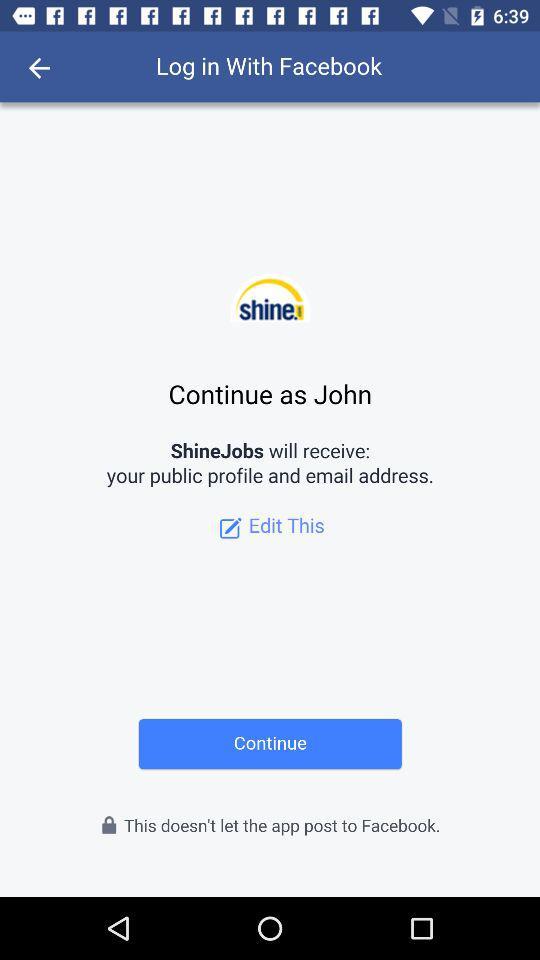By what profile name can we log into "Facebook"? The profile name is John. 